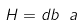<formula> <loc_0><loc_0><loc_500><loc_500>H = d b ^ { \ } a</formula> 